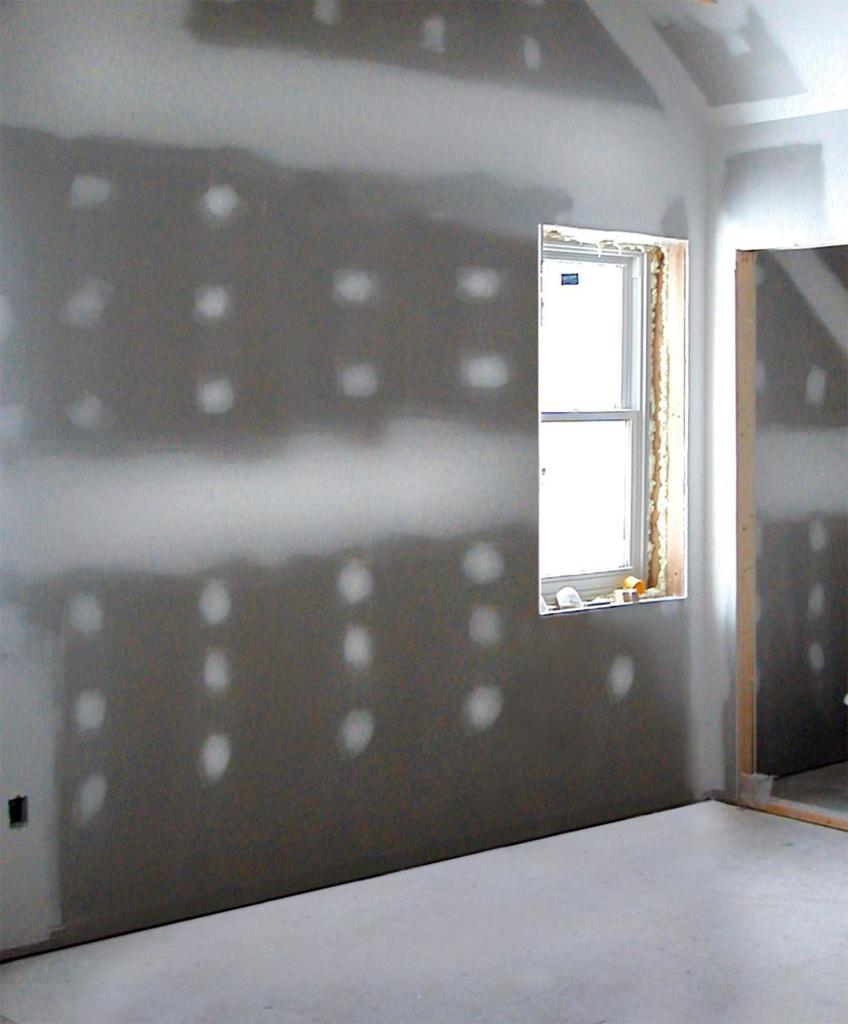What type of opening is present on the wall in the image? There is a glass window on the wall in the image. What can be seen through the opening on the wall? The image does not show what is visible through the window. Is there any access to another room near the window? Yes, there is an entrance to another room beside the window. What type of soda is being served in the room through the window? There is no soda or indication of any beverages being served in the image. 